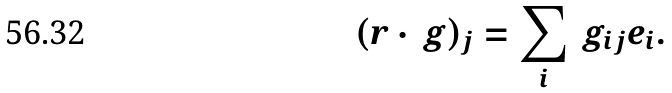<formula> <loc_0><loc_0><loc_500><loc_500>( r \cdot \ g ) _ { j } = \sum _ { i } \ g _ { i j } e _ { i } .</formula> 